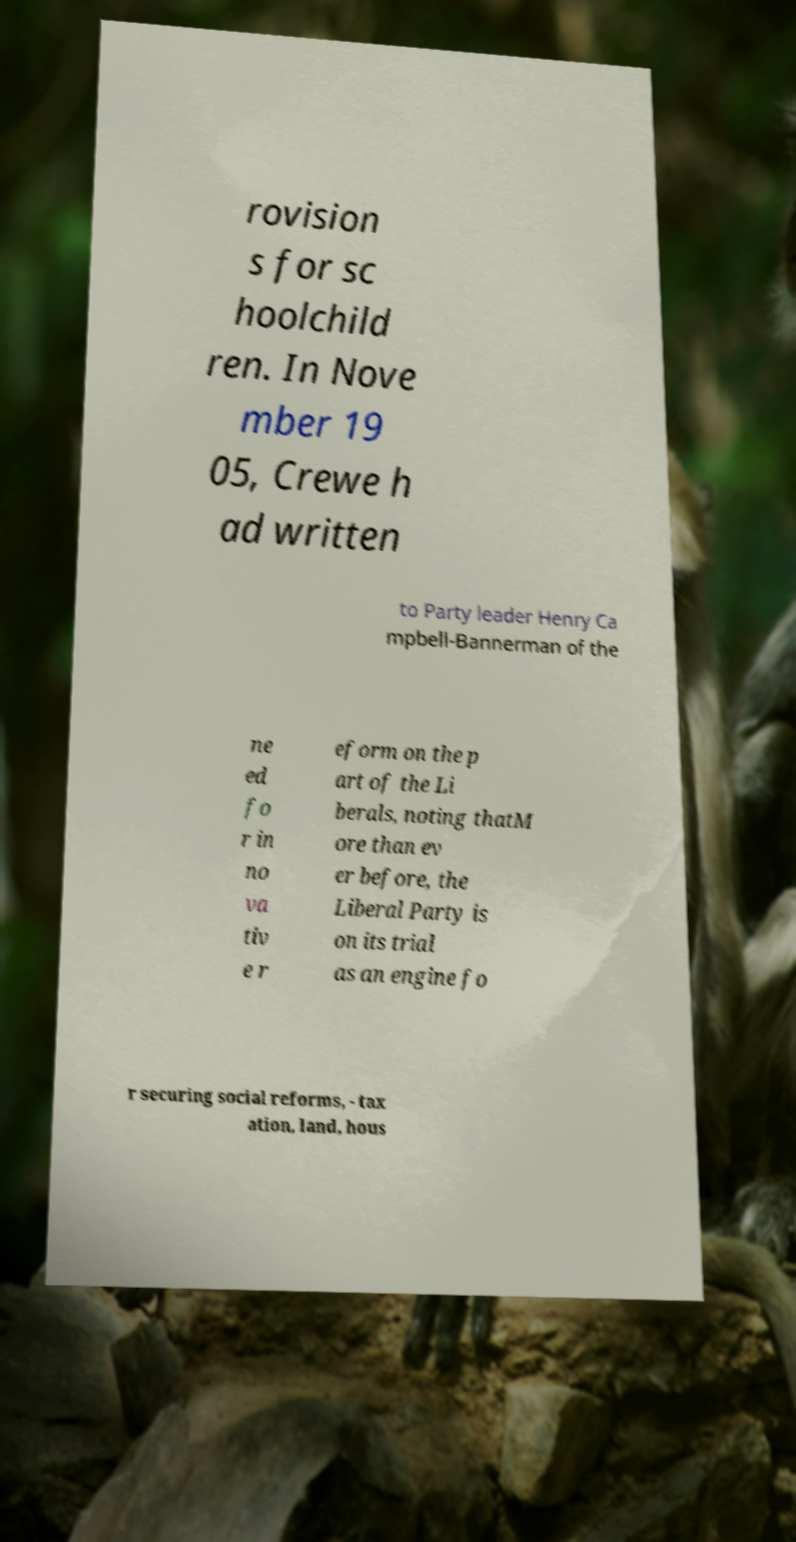Can you read and provide the text displayed in the image?This photo seems to have some interesting text. Can you extract and type it out for me? rovision s for sc hoolchild ren. In Nove mber 19 05, Crewe h ad written to Party leader Henry Ca mpbell-Bannerman of the ne ed fo r in no va tiv e r eform on the p art of the Li berals, noting thatM ore than ev er before, the Liberal Party is on its trial as an engine fo r securing social reforms, - tax ation, land, hous 